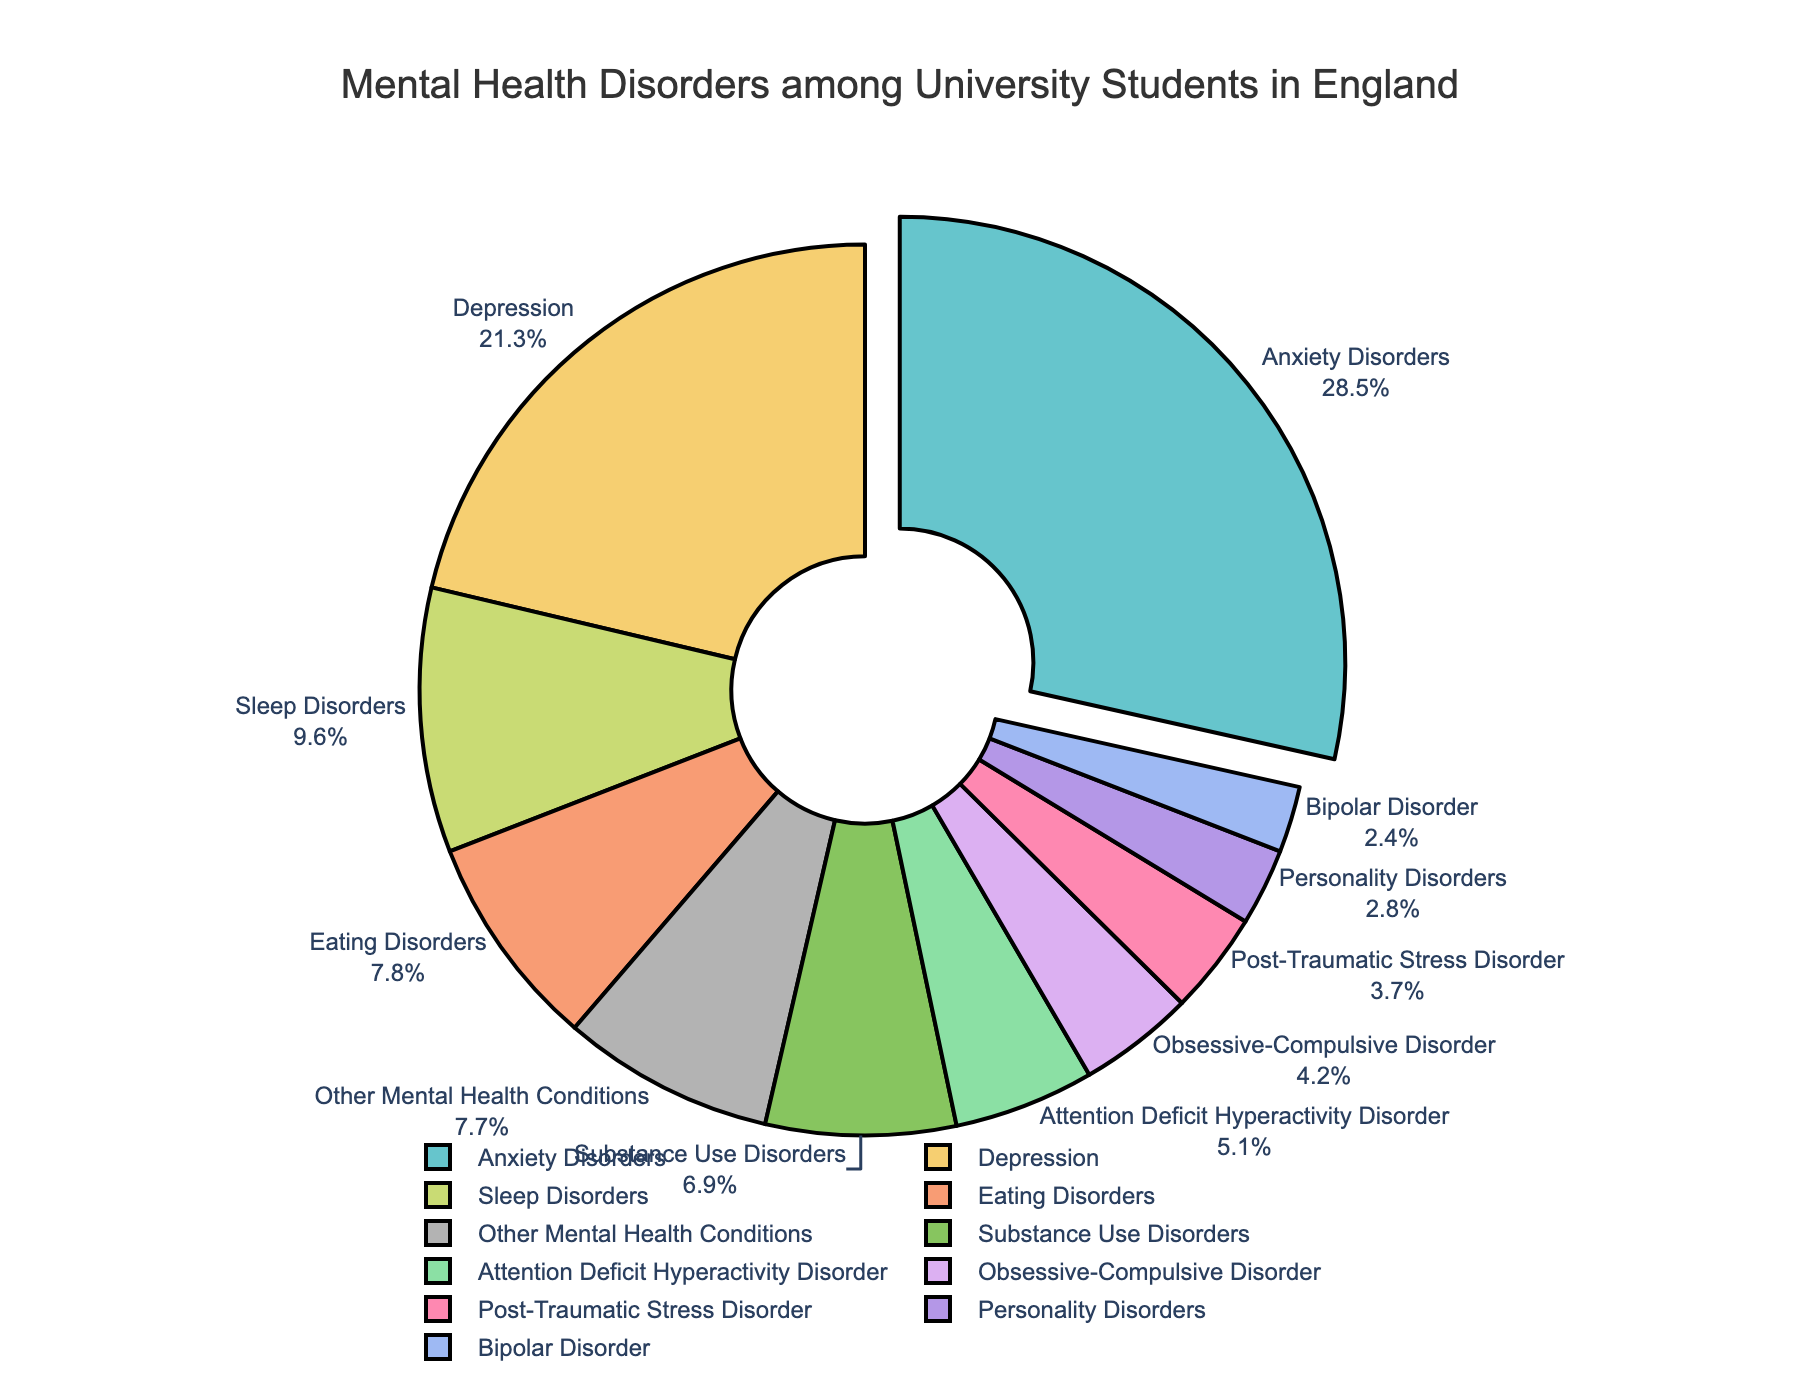Which mental health disorder has the highest percentage among university students in England? The figure's labels show that Anxiety Disorders has the highest percentage.
Answer: Anxiety Disorders Which disorder accounts for the smallest proportion of the total percentage? The figure's labels indicate that Bipolar Disorder has the smallest proportion.
Answer: Bipolar Disorder What is the combined percentage of Depression and Anxiety Disorders? The figure shows that Depression is 21.3% and Anxiety Disorders is 28.5%. Their combined percentage is \( 21.3 + 28.5 \).
Answer: 49.8% Are Substance Use Disorders more prevalent than Eating Disorders among university students? The figure shows that Substance Use Disorders are 6.9% whereas Eating Disorders are 7.8%. Substance Use Disorders are less prevalent.
Answer: No Is the percentage of students with Sleep Disorders higher than the percentage with Attention Deficit Hyperactivity Disorder (ADHD)? The figure shows Sleep Disorders are 9.6% and ADHD is 5.1%. Therefore, Sleep Disorders are higher.
Answer: Yes How much more prevalent are Anxiety Disorders compared to Bipolar Disorder? Anxiety Disorders are 28.5% and Bipolar Disorder is 2.4%. The difference is \( 28.5 - 2.4 \).
Answer: 26.1% What is the percentage difference between Post-Traumatic Stress Disorder (PTSD) and Personality Disorders? PTSD is 3.7% and Personality Disorders are 2.8%. The difference is \( 3.7 - 2.8 \).
Answer: 0.9% Which disorder is depicted with the second-highest percentage in the pie chart? The figure's labels indicate that after Anxiety Disorders, Depression has the second-highest percentage at 21.3%.
Answer: Depression What is the total percentage of disorders that have a prevalence below 5%? The relevant disorders are Obsessive-Compulsive Disorder (4.2%), Bipolar Disorder (2.4%), Post-Traumatic Stress Disorder (3.7%), and Personality Disorders (2.8%). Their combined percentage is \( 4.2 + 2.4 + 3.7 + 2.8 \).
Answer: 13.1% By how much does the percentage of Eating Disorders exceed the percentage of Substance Use Disorders? Eating Disorders are 7.8% and Substance Use Disorders are 6.9%. The difference is \( 7.8 - 6.9 \).
Answer: 0.9% 